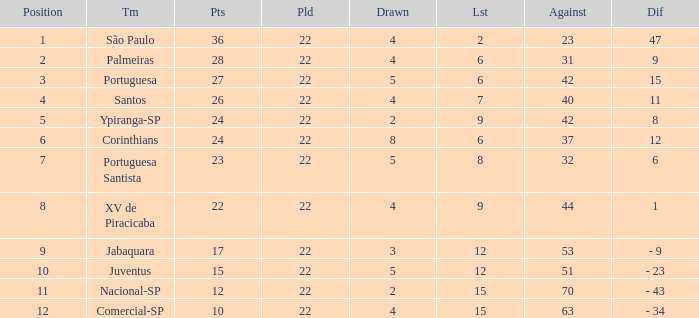Would you mind parsing the complete table? {'header': ['Position', 'Tm', 'Pts', 'Pld', 'Drawn', 'Lst', 'Against', 'Dif'], 'rows': [['1', 'São Paulo', '36', '22', '4', '2', '23', '47'], ['2', 'Palmeiras', '28', '22', '4', '6', '31', '9'], ['3', 'Portuguesa', '27', '22', '5', '6', '42', '15'], ['4', 'Santos', '26', '22', '4', '7', '40', '11'], ['5', 'Ypiranga-SP', '24', '22', '2', '9', '42', '8'], ['6', 'Corinthians', '24', '22', '8', '6', '37', '12'], ['7', 'Portuguesa Santista', '23', '22', '5', '8', '32', '6'], ['8', 'XV de Piracicaba', '22', '22', '4', '9', '44', '1'], ['9', 'Jabaquara', '17', '22', '3', '12', '53', '- 9'], ['10', 'Juventus', '15', '22', '5', '12', '51', '- 23'], ['11', 'Nacional-SP', '12', '22', '2', '15', '70', '- 43'], ['12', 'Comercial-SP', '10', '22', '4', '15', '63', '- 34']]} Which Played has a Lost larger than 9, and a Points smaller than 15, and a Position smaller than 12, and a Drawn smaller than 2? None. 